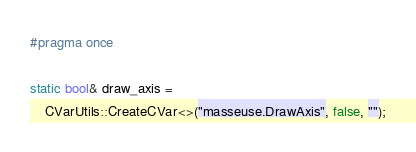Convert code to text. <code><loc_0><loc_0><loc_500><loc_500><_C_>#pragma once

static bool& draw_axis =
    CVarUtils::CreateCVar<>("masseuse.DrawAxis", false, "");


</code> 